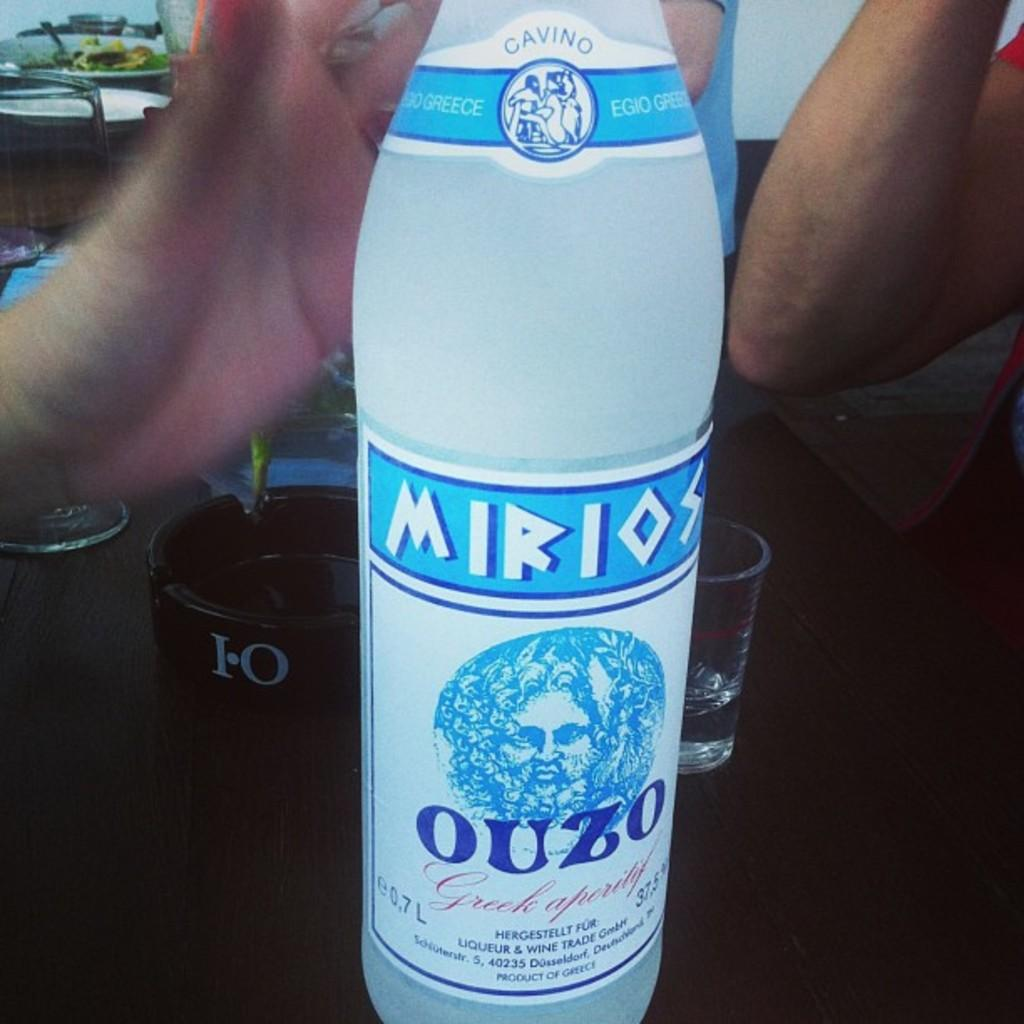<image>
Share a concise interpretation of the image provided. A bottle of Morios Ouzo on a table with two people sitting at the table. 